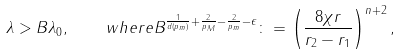<formula> <loc_0><loc_0><loc_500><loc_500>\lambda > B \lambda _ { 0 } , \quad w h e r e B ^ { \frac { 1 } { d ( p _ { m } ) } + \frac { 2 } { p _ { M } } - \frac { 2 } { p _ { m } } - \epsilon } \colon = \left ( \frac { 8 \chi r } { r _ { 2 } - r _ { 1 } } \right ) ^ { n + 2 } ,</formula> 